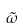Convert formula to latex. <formula><loc_0><loc_0><loc_500><loc_500>\tilde { \omega }</formula> 